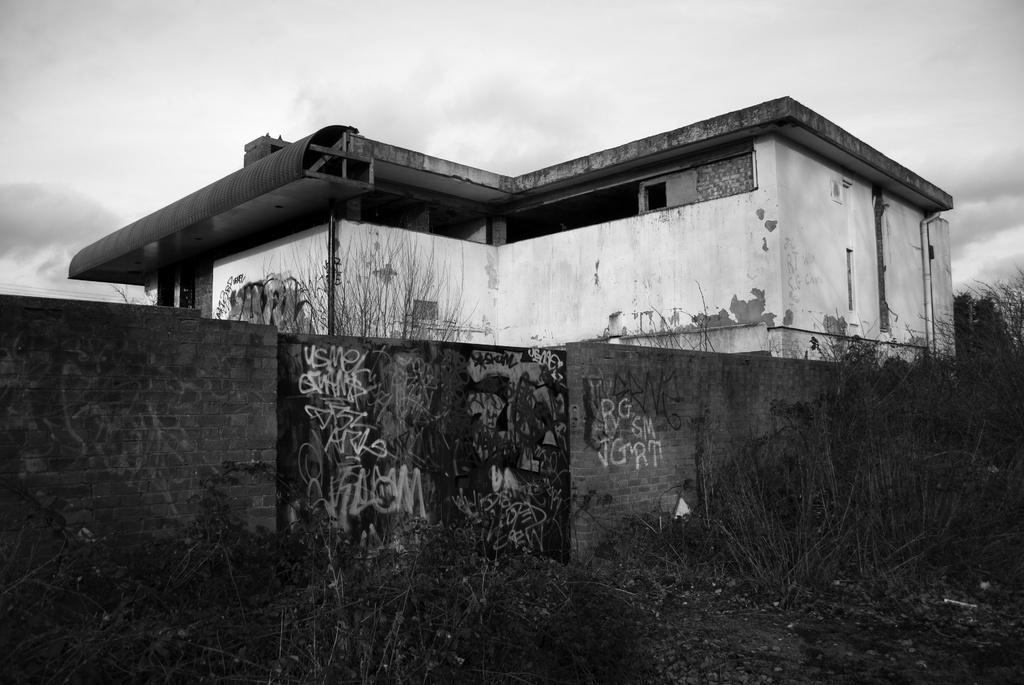What type of vegetation can be seen in the image? There are plants and trees in the image. What type of structures are present in the image? There are walls, a gate, and a building in the image. What type of infrastructure can be seen in the image? There are pipes in the image. What is visible in the background of the image? The sky is visible in the background of the image, with clouds present. How many boats are visible in the image? There are no boats present in the image. What type of decision is being made by the plants in the image? There are no decisions being made by the plants in the image, as plants do not have the ability to make decisions. 